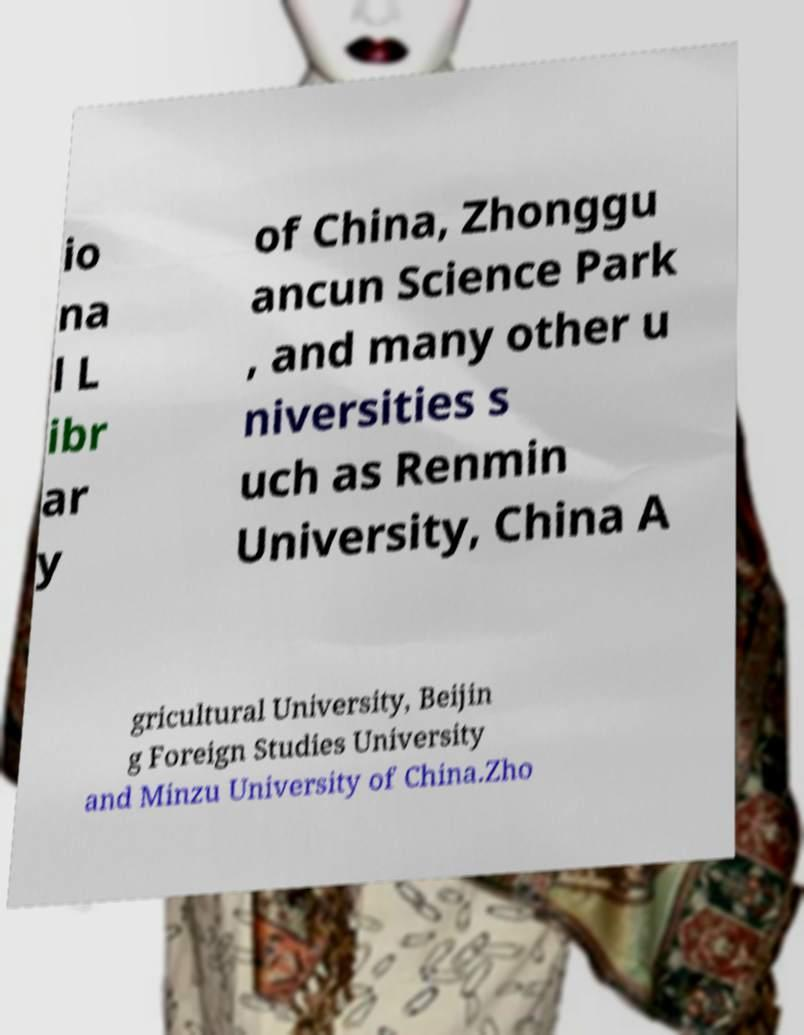There's text embedded in this image that I need extracted. Can you transcribe it verbatim? io na l L ibr ar y of China, Zhonggu ancun Science Park , and many other u niversities s uch as Renmin University, China A gricultural University, Beijin g Foreign Studies University and Minzu University of China.Zho 